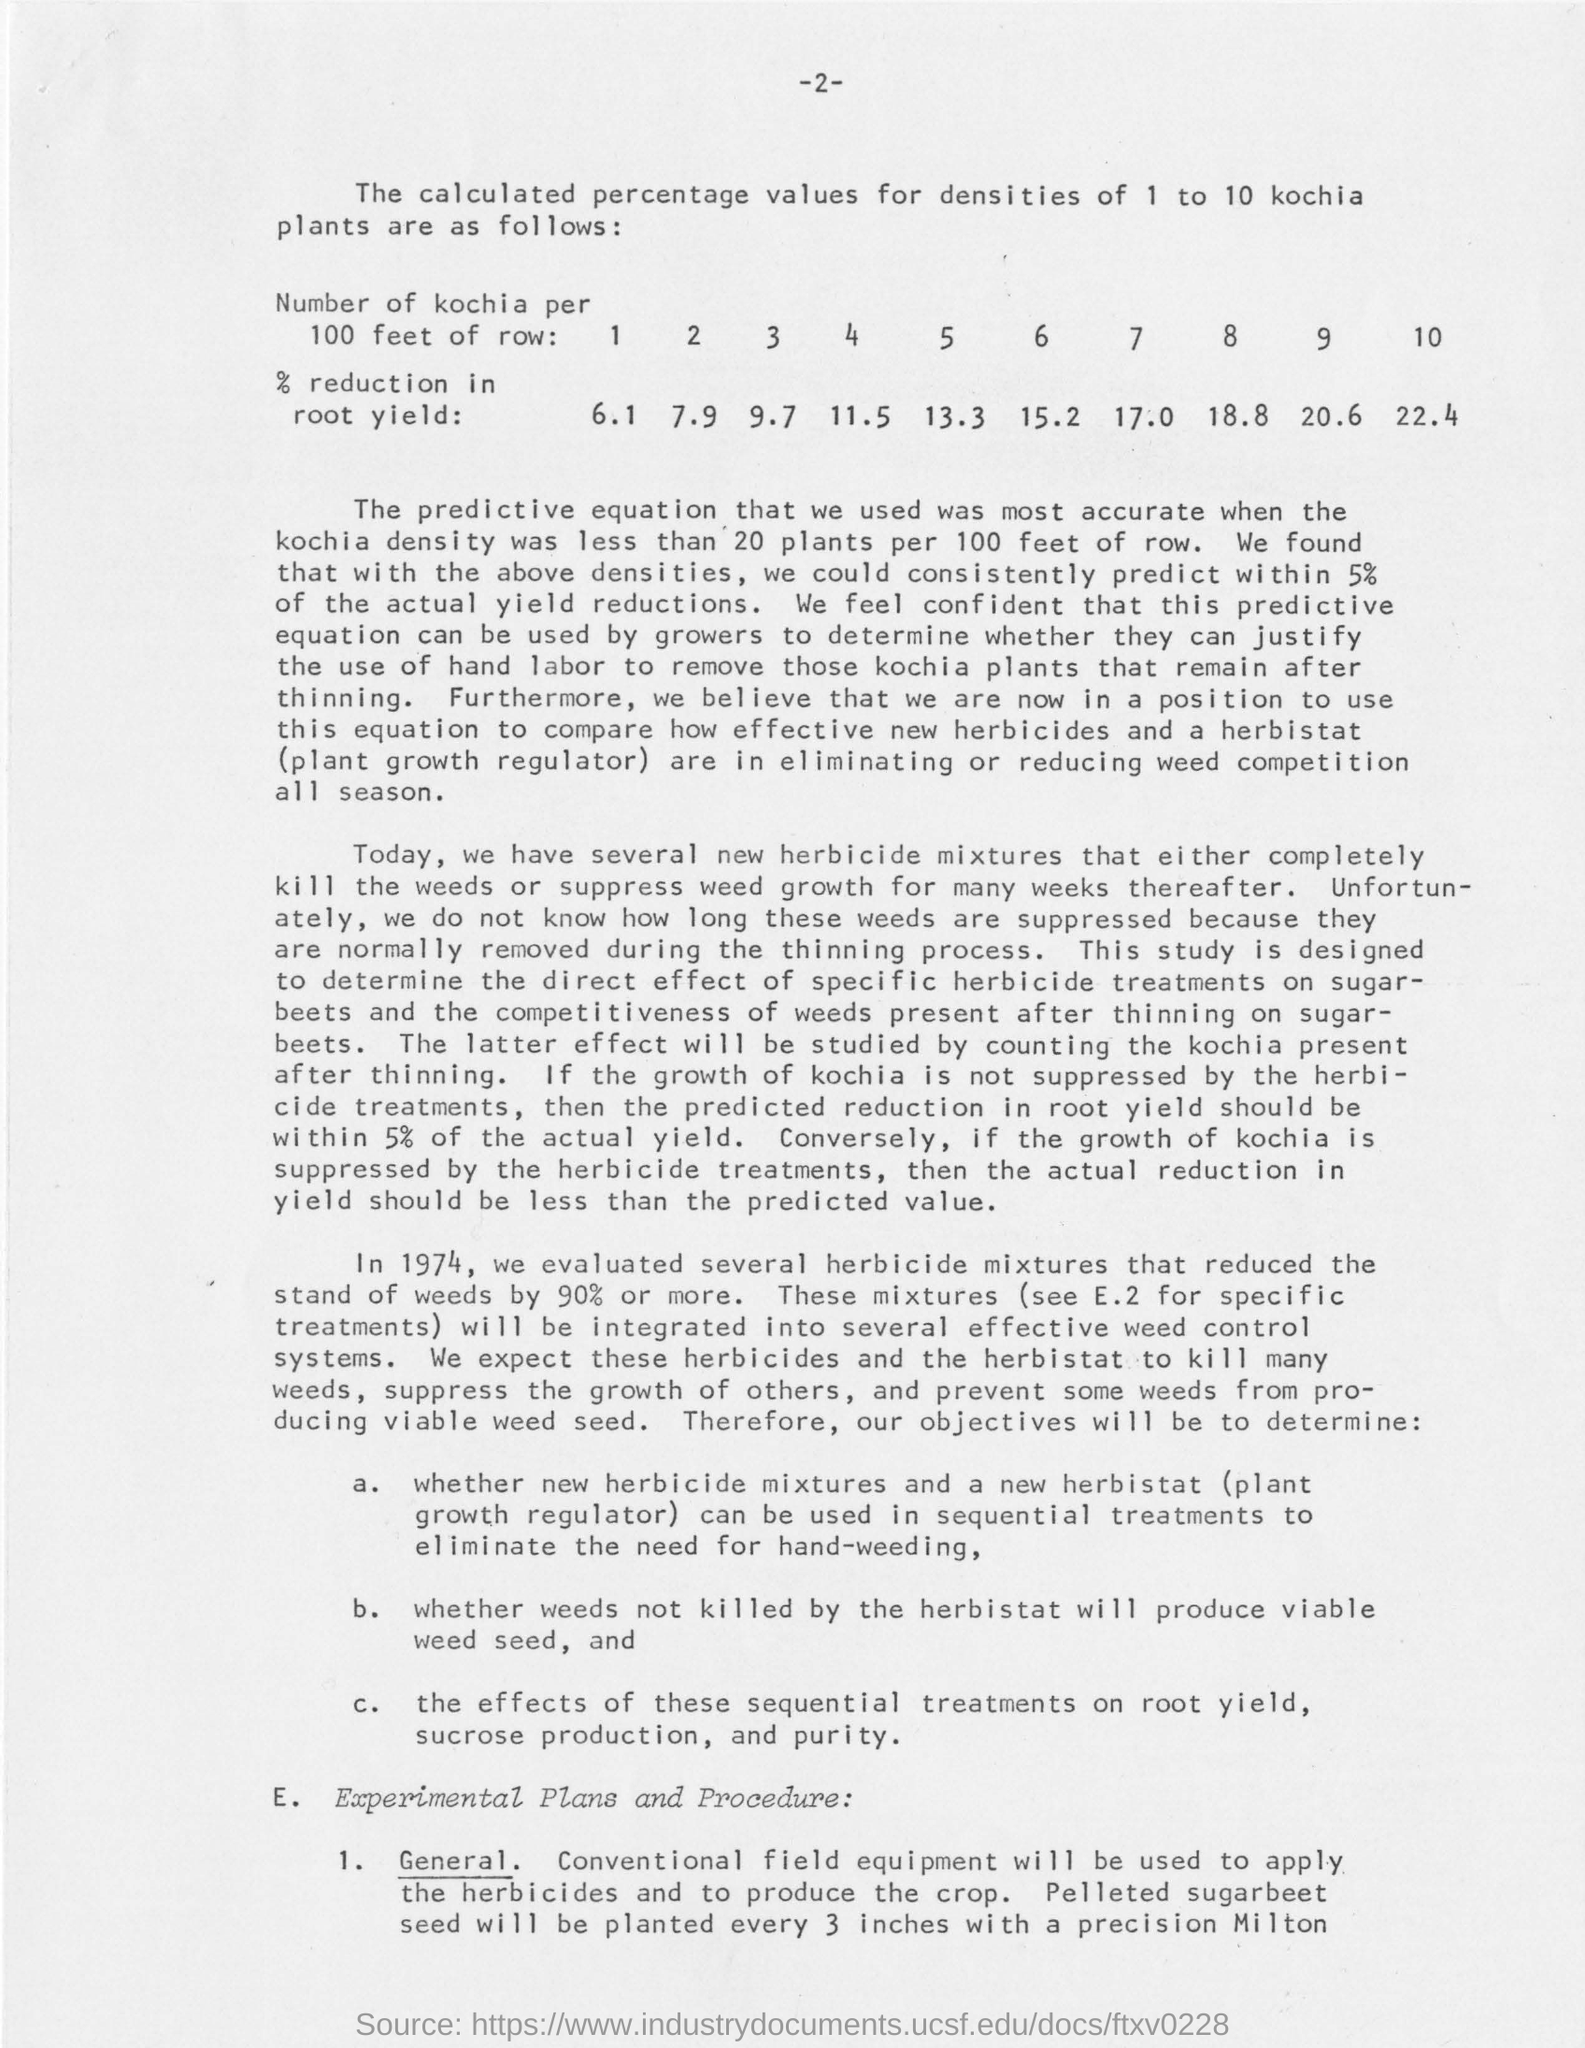Draw attention to some important aspects in this diagram. In 1974, a series of herbicide combinations were tested that effectively reduced weed stands by 90% or more. The actual yield reductions observed are consistent with the predicted values, with a deviation of no more than 5%. Based on the data provided, the rate of reduction in root yield for the 4 Kochi plants per 100 feet of row is significantly affected by the densities values, with a maximum reduction of 32.7% at a density of 11.5. In 1974, a study was conducted to evaluate the effectiveness of various herbicide mixtures in reducing the growth of weeds. The results showed that when these herbicide mixtures were used, the rate of stand of weeds was reduced by an average of 90%. 